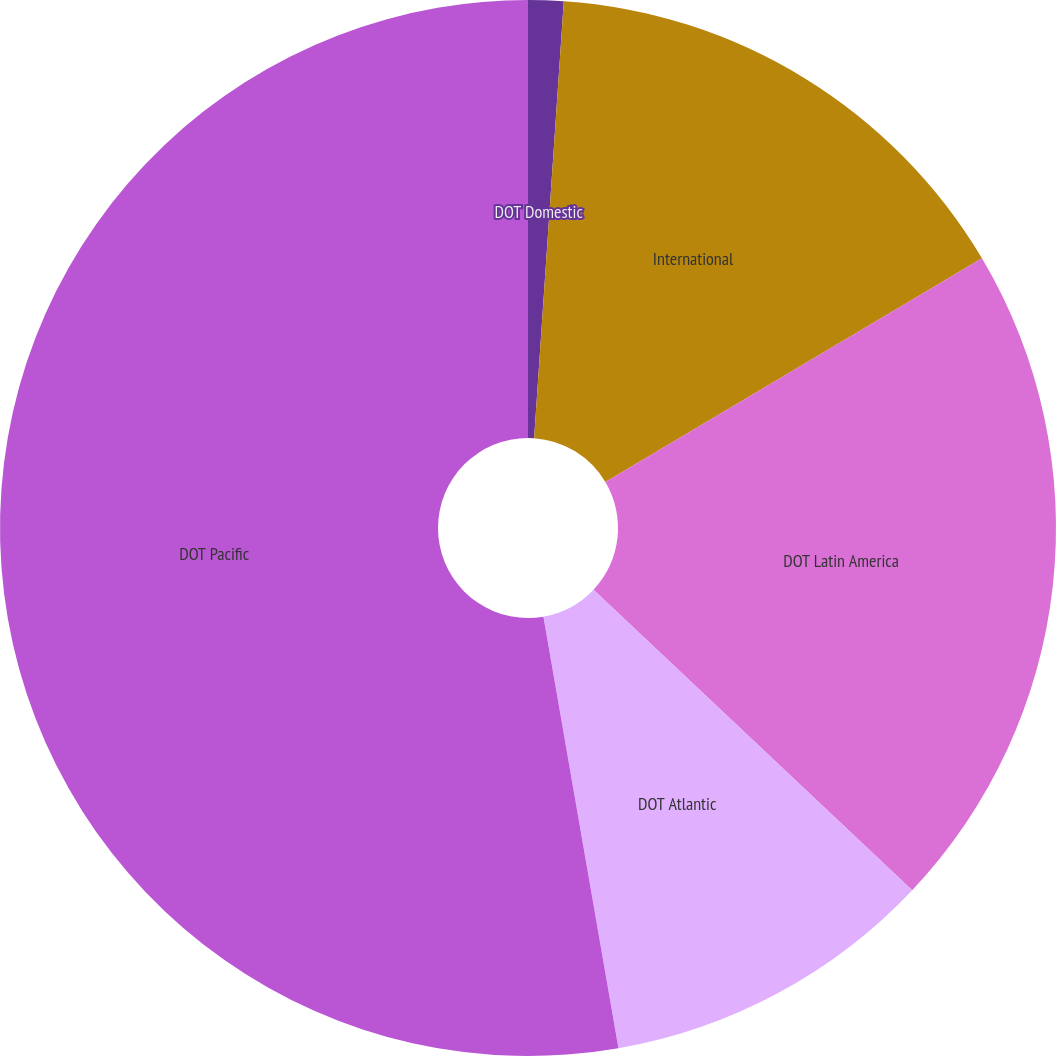<chart> <loc_0><loc_0><loc_500><loc_500><pie_chart><fcel>DOT Domestic<fcel>International<fcel>DOT Latin America<fcel>DOT Atlantic<fcel>DOT Pacific<nl><fcel>1.08%<fcel>15.39%<fcel>20.56%<fcel>10.23%<fcel>52.74%<nl></chart> 